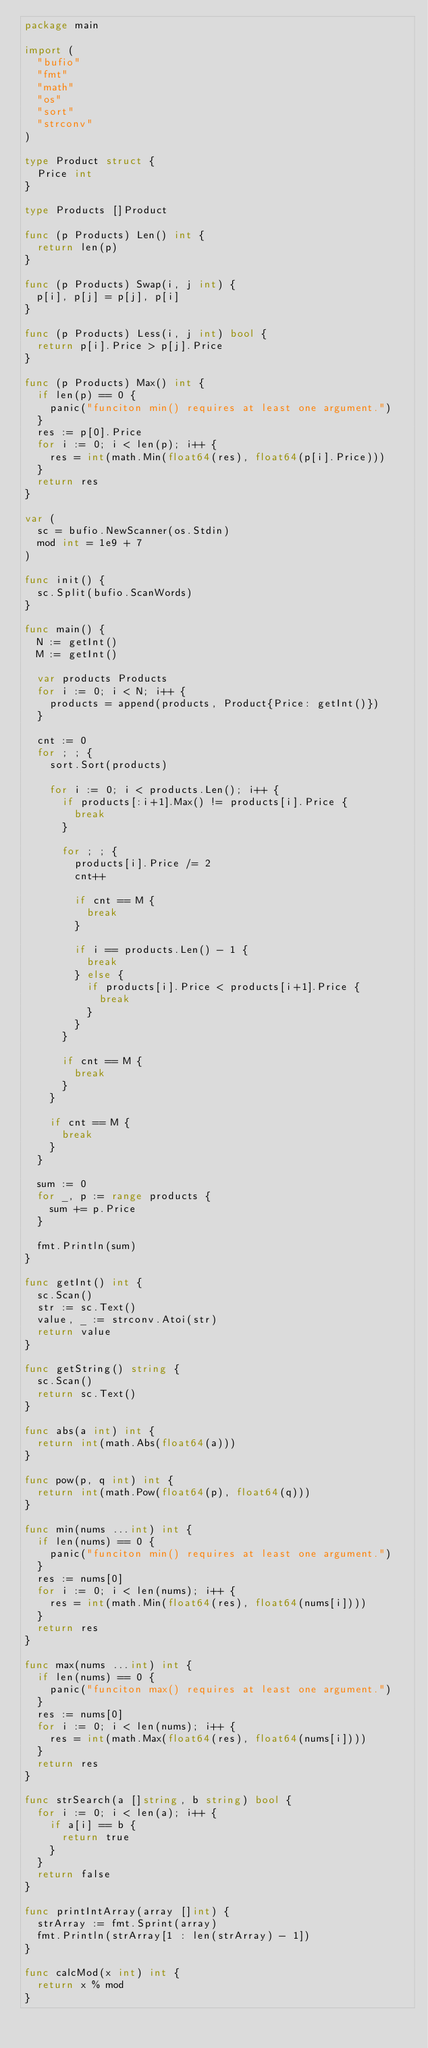Convert code to text. <code><loc_0><loc_0><loc_500><loc_500><_Go_>package main

import (
	"bufio"
	"fmt"
	"math"
	"os"
	"sort"
	"strconv"
)

type Product struct {
	Price int
}

type Products []Product

func (p Products) Len() int {
	return len(p)
}

func (p Products) Swap(i, j int) {
	p[i], p[j] = p[j], p[i]
}

func (p Products) Less(i, j int) bool {
	return p[i].Price > p[j].Price
}

func (p Products) Max() int {
	if len(p) == 0 {
		panic("funciton min() requires at least one argument.")
	}
	res := p[0].Price
	for i := 0; i < len(p); i++ {
		res = int(math.Min(float64(res), float64(p[i].Price)))
	}
	return res
}

var (
	sc = bufio.NewScanner(os.Stdin)
	mod int = 1e9 + 7
)

func init() {
	sc.Split(bufio.ScanWords)
}

func main() {
	N := getInt()
	M := getInt()

	var products Products
	for i := 0; i < N; i++ {
		products = append(products, Product{Price: getInt()})
	}

	cnt := 0
	for ; ; {
		sort.Sort(products)

		for i := 0; i < products.Len(); i++ {
			if products[:i+1].Max() != products[i].Price {
				break
			}

			for ; ; {
				products[i].Price /= 2
				cnt++

				if cnt == M {
					break
				}

				if i == products.Len() - 1 {
					break
				} else {
					if products[i].Price < products[i+1].Price {
						break
					}
				}
			}

			if cnt == M {
				break
			}
		}

		if cnt == M {
			break
		}
	}

	sum := 0
	for _, p := range products {
		sum += p.Price
	}

	fmt.Println(sum)
}

func getInt() int {
	sc.Scan()
	str := sc.Text()
	value, _ := strconv.Atoi(str)
	return value
}

func getString() string {
	sc.Scan()
	return sc.Text()
}

func abs(a int) int {
	return int(math.Abs(float64(a)))
}

func pow(p, q int) int {
	return int(math.Pow(float64(p), float64(q)))
}

func min(nums ...int) int {
	if len(nums) == 0 {
		panic("funciton min() requires at least one argument.")
	}
	res := nums[0]
	for i := 0; i < len(nums); i++ {
		res = int(math.Min(float64(res), float64(nums[i])))
	}
	return res
}

func max(nums ...int) int {
	if len(nums) == 0 {
		panic("funciton max() requires at least one argument.")
	}
	res := nums[0]
	for i := 0; i < len(nums); i++ {
		res = int(math.Max(float64(res), float64(nums[i])))
	}
	return res
}

func strSearch(a []string, b string) bool {
	for i := 0; i < len(a); i++ {
		if a[i] == b {
			return true
		}
	}
	return false
}

func printIntArray(array []int) {
	strArray := fmt.Sprint(array)
	fmt.Println(strArray[1 : len(strArray) - 1])
}

func calcMod(x int) int {
	return x % mod
}
</code> 